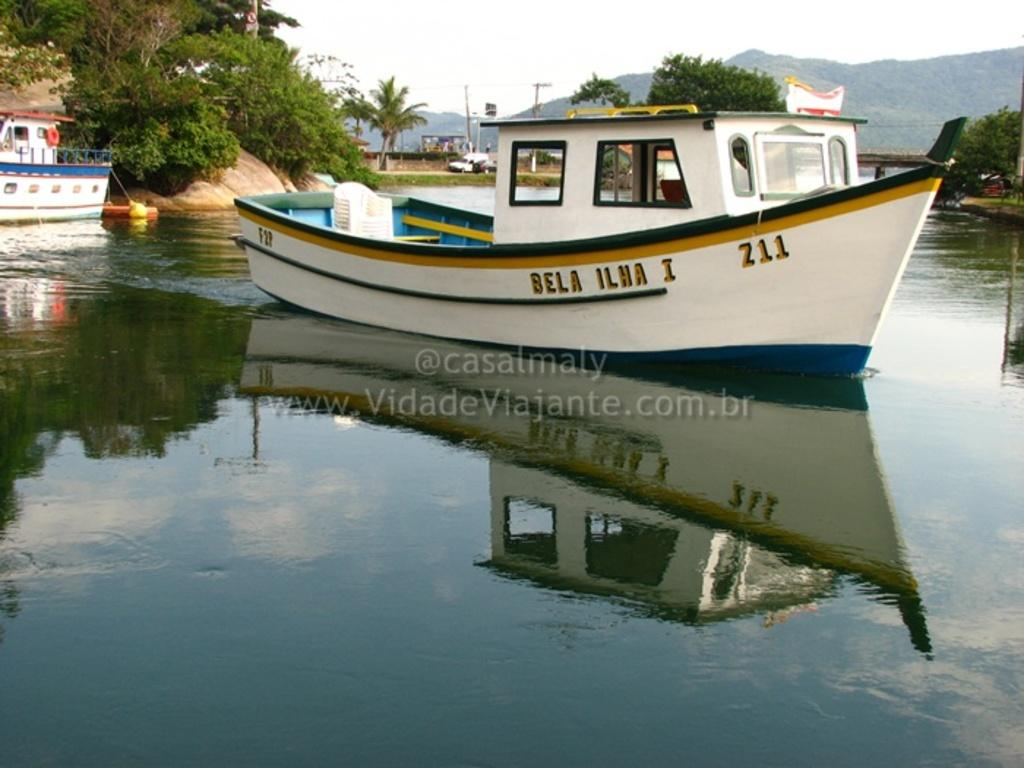What is the main subject of the image? The main subject of the image is a white color boat on the surface of water. What can be seen behind the boat? Trees and poles are visible behind the boat. What is in the background of the image? Mountains are visible in the background. Are there any other boats in the image? Yes, there is another boat on the left side of the image. What type of ant is crawling on the boat in the image? There are no ants present on the boat in the image. Is there an army visible in the image? There is no army present in the image. 